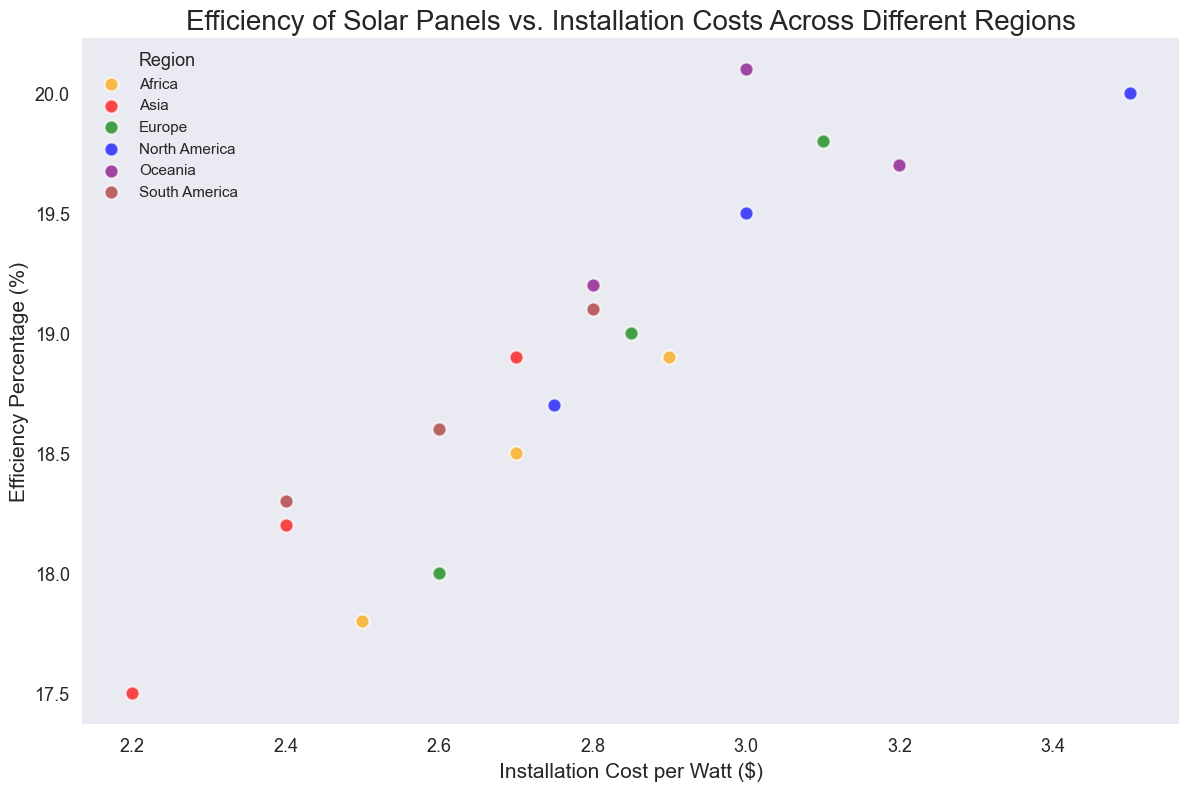What region has the highest average efficiency percentage? First, calculate the average efficiency percentage for each region. North America: (19.5 + 18.7 + 20.0)/3 = 19.4, Europe: (18.0 + 19.0 + 19.8)/3 = 18.93, Asia: (17.5 + 18.2 + 18.9)/3 = 18.2, Oceania: (19.2 + 20.1 + 19.7)/3 = 19.67, Africa: (17.8 + 18.5 + 18.9)/3 = 18.4, South America: (18.3 + 18.6 + 19.1)/3 = 18.67. Hence, Oceania has the highest average efficiency.
Answer: Oceania Which region has the most installations with costs above $3.00 per watt? Count the number of data points for each region where the installation cost is above $3.00 per watt. North America: 1 (3.50), Europe: 1 (3.10), Asia: 0, Oceania: 3 (3.00, 3.20), Africa: 0, South America: 0. Therefore, Oceania has the most installations with costs above $3.00 per watt.
Answer: Oceania Among the regions, which has the lowest installation cost per watt with an efficiency percentage above 18? Identify the installation costs with efficiency above 18 for each region. North America: No data points, Europe: 2.85 (19.0) and 3.10 (19.8), Asia: 2.40 (18.2) and 2.70 (18.9), Oceania: 2.80 (19.2), 3.00 (20.1) and 3.20 (19.7), Africa: 2.70 (18.5) and 2.90 (18.9), South America: 2.40 (18.3), 2.60 (18.6) and 2.80 (19.1). The lowest installation cost with efficiency above 18 is $2.40 per watt in South America.
Answer: South America Which region generally has the highest efficiency percentages regardless of installation costs? By visually inspecting the data points, we notice that Oceania's data points are mostly near or above 19.0 in efficiency, indicating that this region generally has high efficiency percentages irrespective of cost.
Answer: Oceania Does any region exhibit both low installation costs and high efficiency? To determine this, look for regions with data points showing low costs (below $2.60 per watt) and high efficiency (above 18%). South America and Asia feature points at $2.40 per watt with efficiencies of 18.3 and 18.2 respectively, but they do not meet the high efficiency threshold above 18%. Hence, no region shows both low costs and high efficiency as defined.
Answer: No What is the range of installation costs for solar panels in North America? Identify the minimum and maximum costs for North America: $2.75 (min) and $3.50 (max). The range is the difference between max and min, which is $3.50 - $2.75 = $0.75.
Answer: $0.75 